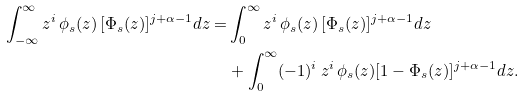<formula> <loc_0><loc_0><loc_500><loc_500>\int _ { - \infty } ^ { \infty } z ^ { i } \, \phi _ { s } ( z ) \, [ \Phi _ { s } ( z ) ] ^ { j + \alpha - 1 } d z = & \int _ { 0 } ^ { \infty } z ^ { i } \, \phi _ { s } ( z ) \, [ \Phi _ { s } ( z ) ] ^ { j + \alpha - 1 } d z \\ & + \int _ { 0 } ^ { \infty } ( - 1 ) ^ { i } \, z ^ { i } \, \phi _ { s } ( z ) [ 1 - \Phi _ { s } ( z ) ] ^ { j + \alpha - 1 } d z .</formula> 